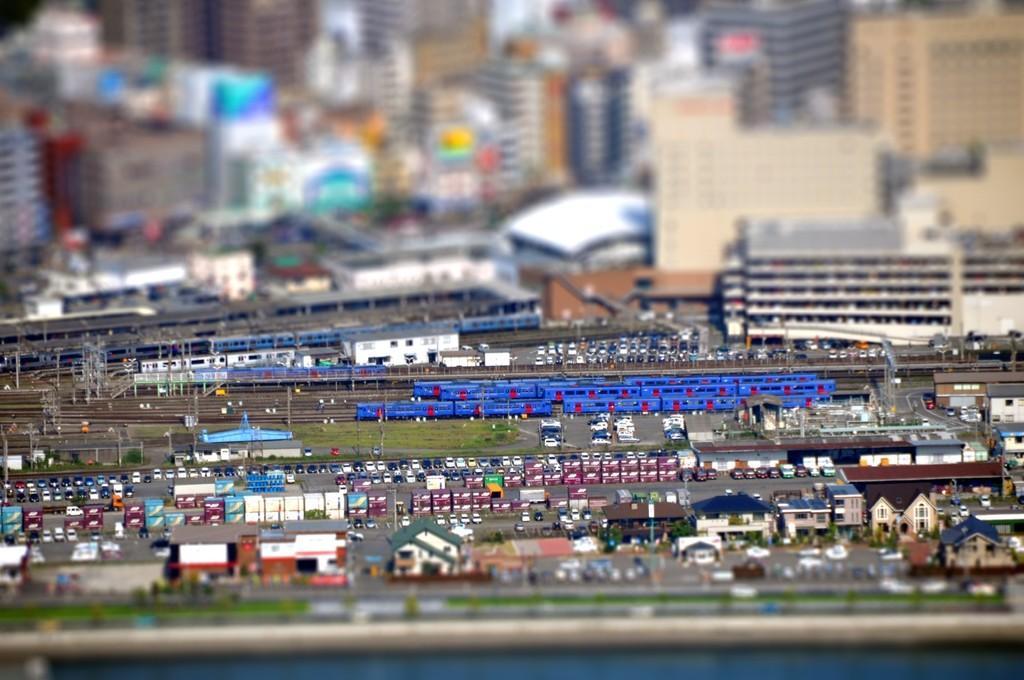Describe this image in one or two sentences. In this image we can see many toys. This part of the image is blurred. 